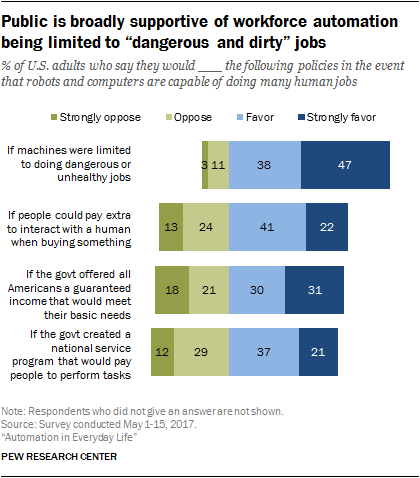Draw attention to some important aspects in this diagram. The average value of the light green bar is 11.5. There is no bar with a value of 40. 